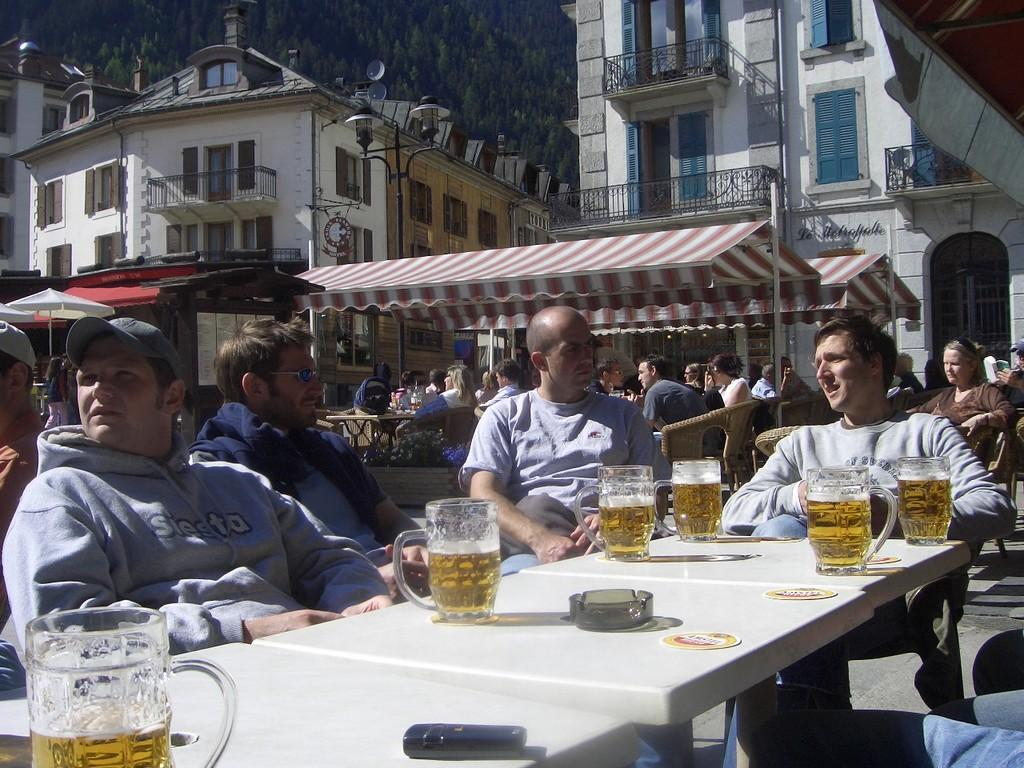What are the people in the image doing? The people in the image are sitting on chairs. What is in front of the people? There is a table in front of the people. What can be seen on the table? There are glasses on the table. What can be seen in the background of the image? There are buildings and trees in the background of the image. What type of can is visible on the table in the image? There is no can present on the table in the image; only glasses are visible. 